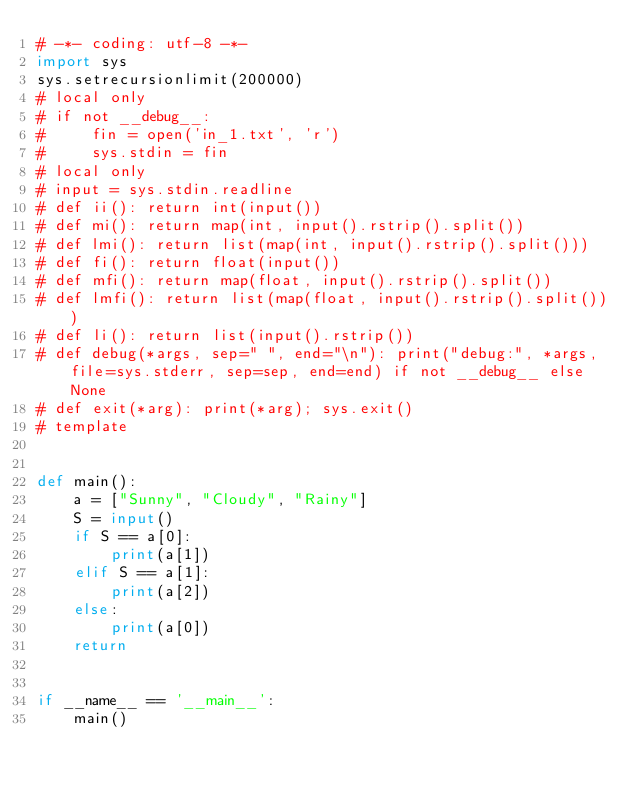Convert code to text. <code><loc_0><loc_0><loc_500><loc_500><_Python_># -*- coding: utf-8 -*-
import sys
sys.setrecursionlimit(200000)
# local only
# if not __debug__:
#     fin = open('in_1.txt', 'r')
#     sys.stdin = fin
# local only
# input = sys.stdin.readline
# def ii(): return int(input())
# def mi(): return map(int, input().rstrip().split())
# def lmi(): return list(map(int, input().rstrip().split()))
# def fi(): return float(input())
# def mfi(): return map(float, input().rstrip().split())
# def lmfi(): return list(map(float, input().rstrip().split()))
# def li(): return list(input().rstrip())
# def debug(*args, sep=" ", end="\n"): print("debug:", *args, file=sys.stderr, sep=sep, end=end) if not __debug__ else None
# def exit(*arg): print(*arg); sys.exit()
# template


def main():
    a = ["Sunny", "Cloudy", "Rainy"]
    S = input()
    if S == a[0]:
        print(a[1])
    elif S == a[1]:
        print(a[2])
    else:
        print(a[0])
    return


if __name__ == '__main__':
    main()
</code> 